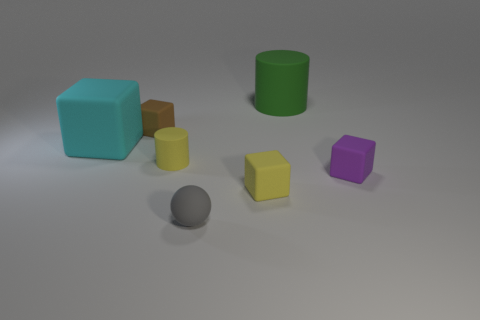There is a matte thing that is the same color as the small cylinder; what size is it?
Your response must be concise. Small. Is there a tiny object that has the same color as the tiny cylinder?
Provide a short and direct response. Yes. There is a small cylinder; is its color the same as the rubber cube in front of the purple matte cube?
Offer a terse response. Yes. There is a rubber block in front of the purple matte block; is its color the same as the tiny cylinder?
Offer a terse response. Yes. What shape is the object that is the same color as the tiny cylinder?
Your response must be concise. Cube. There is a tiny object that is the same color as the tiny cylinder; what material is it?
Provide a short and direct response. Rubber. What is the big green thing made of?
Keep it short and to the point. Rubber. How many other objects are the same color as the small matte cylinder?
Your response must be concise. 1. Do the large cylinder and the matte sphere have the same color?
Keep it short and to the point. No. How many cyan rubber things are there?
Provide a succinct answer. 1. 